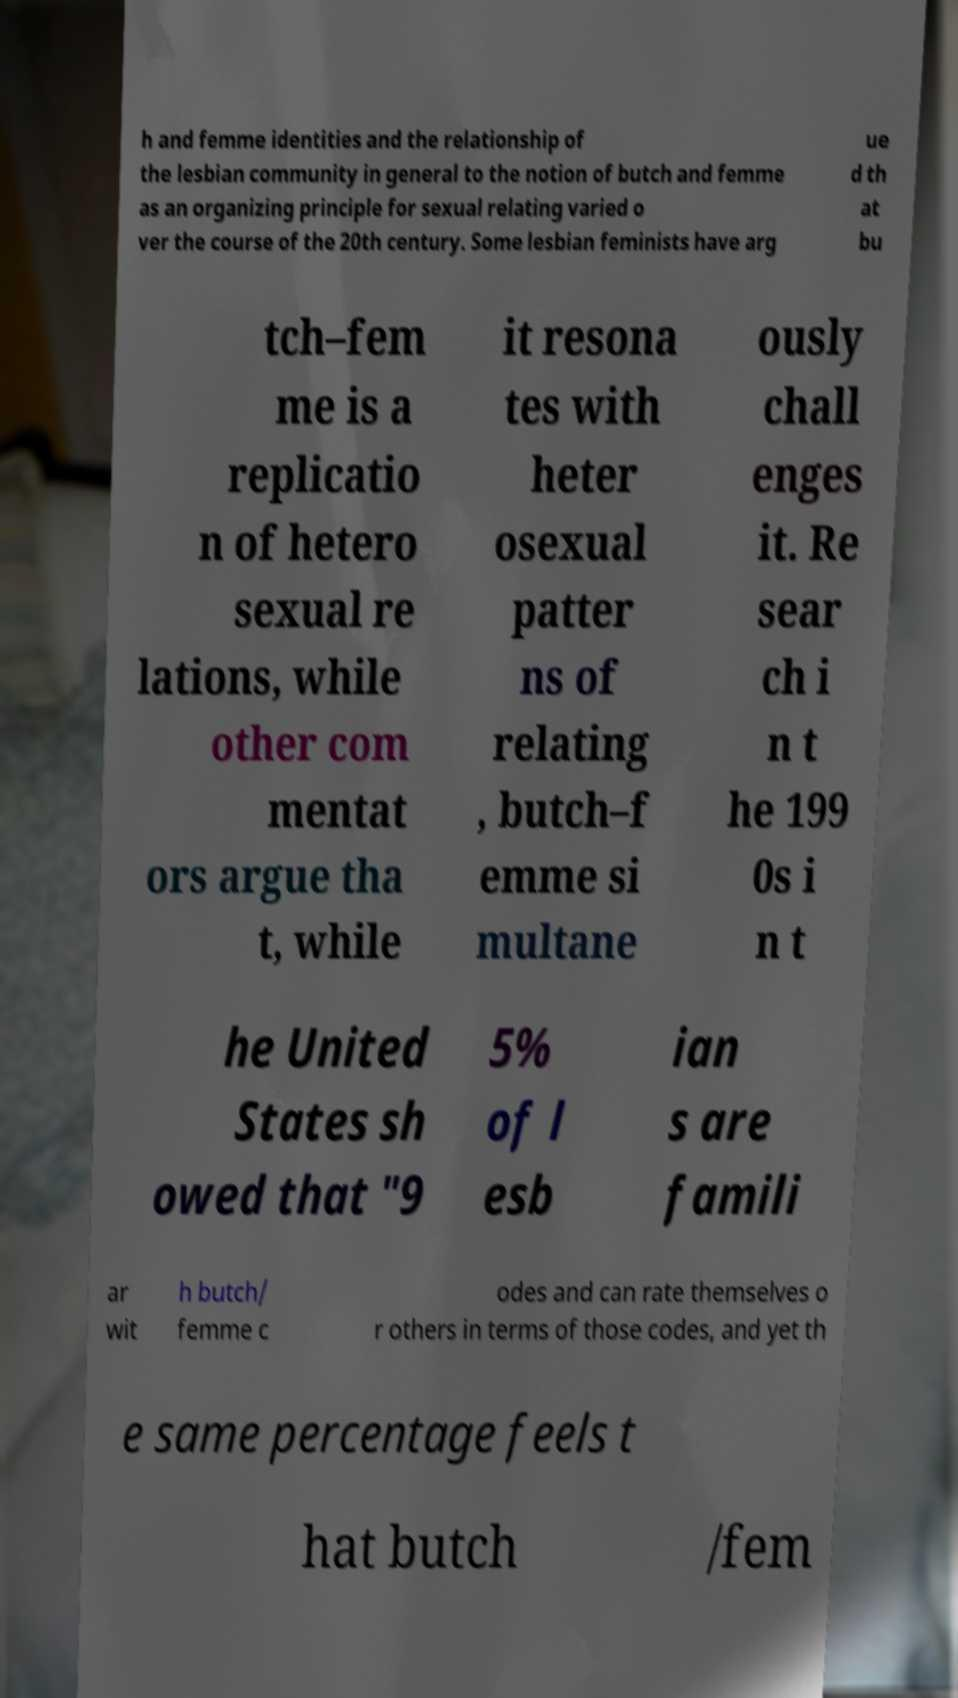Can you read and provide the text displayed in the image?This photo seems to have some interesting text. Can you extract and type it out for me? h and femme identities and the relationship of the lesbian community in general to the notion of butch and femme as an organizing principle for sexual relating varied o ver the course of the 20th century. Some lesbian feminists have arg ue d th at bu tch–fem me is a replicatio n of hetero sexual re lations, while other com mentat ors argue tha t, while it resona tes with heter osexual patter ns of relating , butch–f emme si multane ously chall enges it. Re sear ch i n t he 199 0s i n t he United States sh owed that "9 5% of l esb ian s are famili ar wit h butch/ femme c odes and can rate themselves o r others in terms of those codes, and yet th e same percentage feels t hat butch /fem 